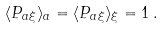<formula> <loc_0><loc_0><loc_500><loc_500>\langle P _ { a \xi } \rangle _ { a } = \langle P _ { a \xi } \rangle _ { \xi } = 1 \, .</formula> 